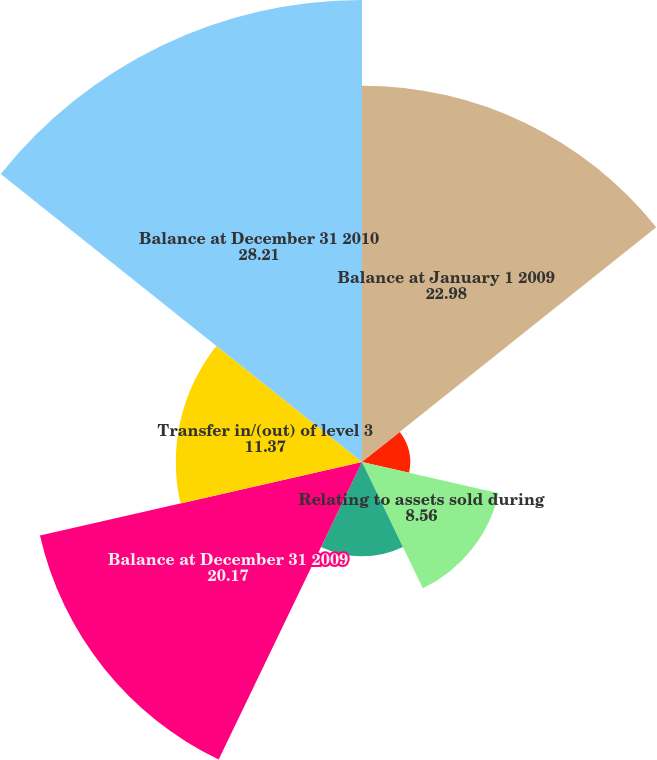<chart> <loc_0><loc_0><loc_500><loc_500><pie_chart><fcel>Balance at January 1 2009<fcel>Relating to assets still held<fcel>Relating to assets sold during<fcel>Purchases sales and<fcel>Balance at December 31 2009<fcel>Transfer in/(out) of level 3<fcel>Balance at December 31 2010<nl><fcel>22.98%<fcel>2.95%<fcel>8.56%<fcel>5.76%<fcel>20.17%<fcel>11.37%<fcel>28.21%<nl></chart> 